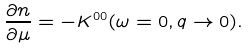<formula> <loc_0><loc_0><loc_500><loc_500>\frac { \partial n } { \partial \mu } = - K ^ { 0 0 } ( \omega = 0 , q \rightarrow 0 ) .</formula> 